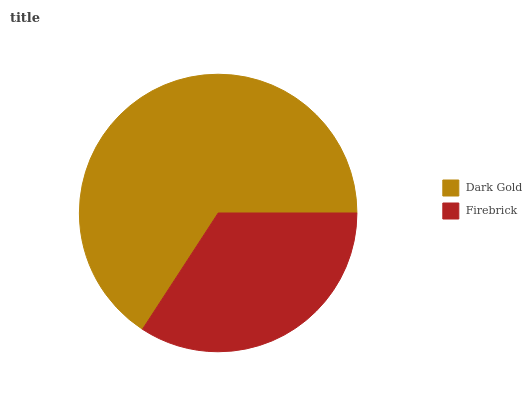Is Firebrick the minimum?
Answer yes or no. Yes. Is Dark Gold the maximum?
Answer yes or no. Yes. Is Firebrick the maximum?
Answer yes or no. No. Is Dark Gold greater than Firebrick?
Answer yes or no. Yes. Is Firebrick less than Dark Gold?
Answer yes or no. Yes. Is Firebrick greater than Dark Gold?
Answer yes or no. No. Is Dark Gold less than Firebrick?
Answer yes or no. No. Is Dark Gold the high median?
Answer yes or no. Yes. Is Firebrick the low median?
Answer yes or no. Yes. Is Firebrick the high median?
Answer yes or no. No. Is Dark Gold the low median?
Answer yes or no. No. 